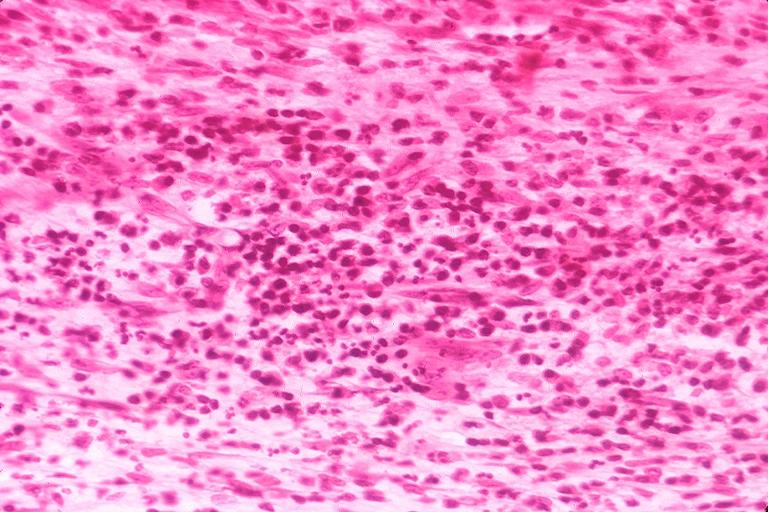what does this image show?
Answer the question using a single word or phrase. Chronic pulpitis 